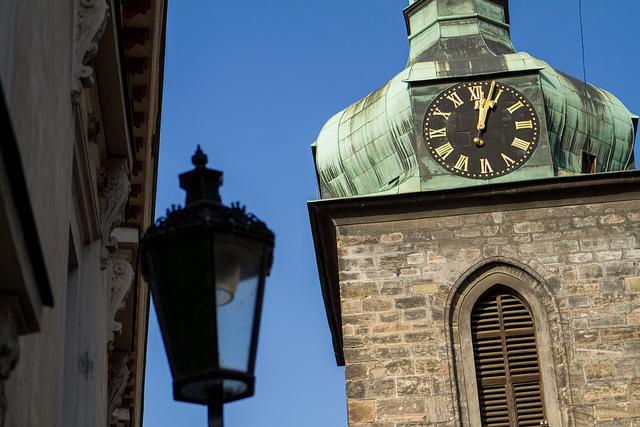What time does the clock face read?
Keep it brief. 12:03. What color are the hands of the clock?
Short answer required. Gold. What number is the small hand on?
Quick response, please. 12. Is the sky clear?
Keep it brief. Yes. What time does the clock say?
Answer briefly. 12:03. Is there frost on the window sill?
Answer briefly. No. Who invented the idea of Time?
Write a very short answer. Father time. What is the last number shown?
Short answer required. 12. What time is it?
Be succinct. 12:03. 